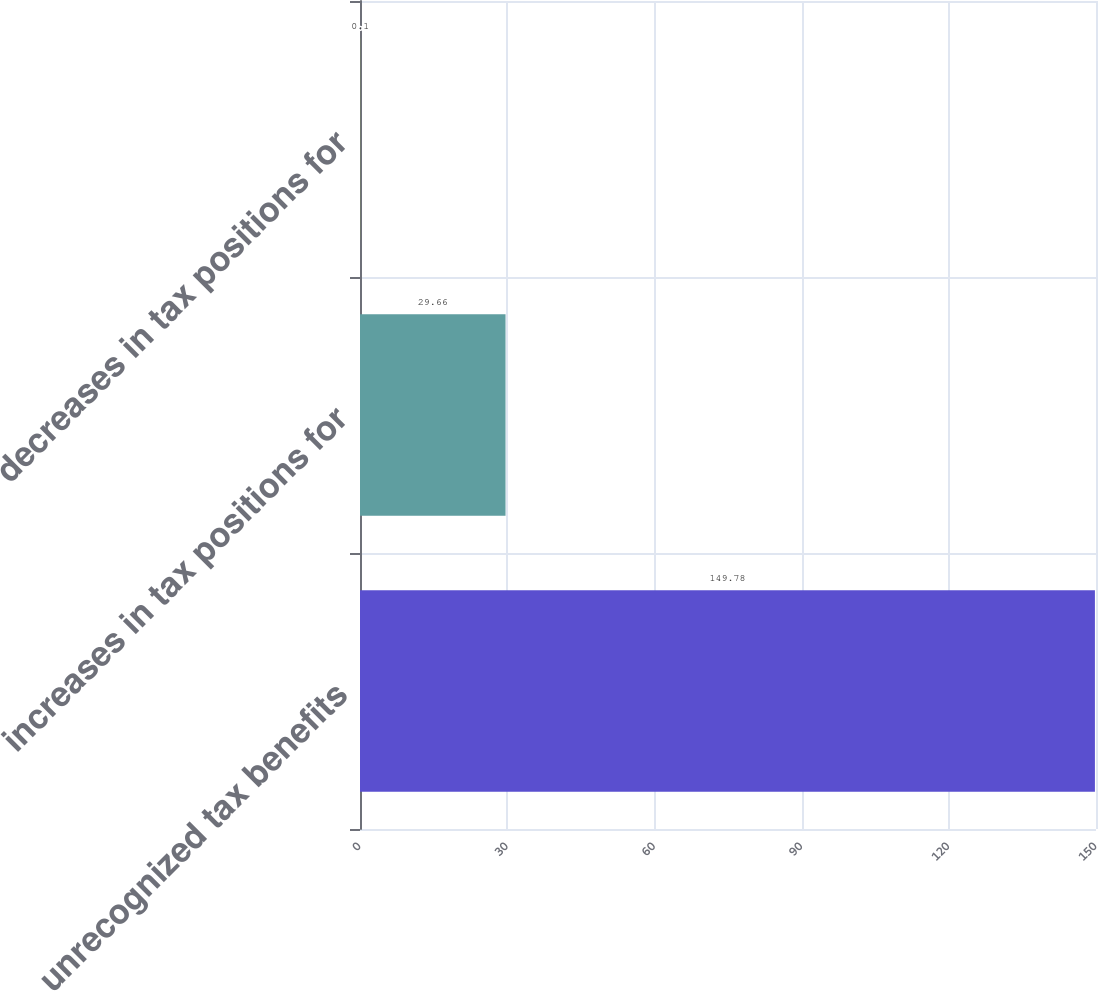<chart> <loc_0><loc_0><loc_500><loc_500><bar_chart><fcel>unrecognized tax benefits<fcel>increases in tax positions for<fcel>decreases in tax positions for<nl><fcel>149.78<fcel>29.66<fcel>0.1<nl></chart> 